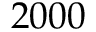Convert formula to latex. <formula><loc_0><loc_0><loc_500><loc_500>2 0 0 0</formula> 